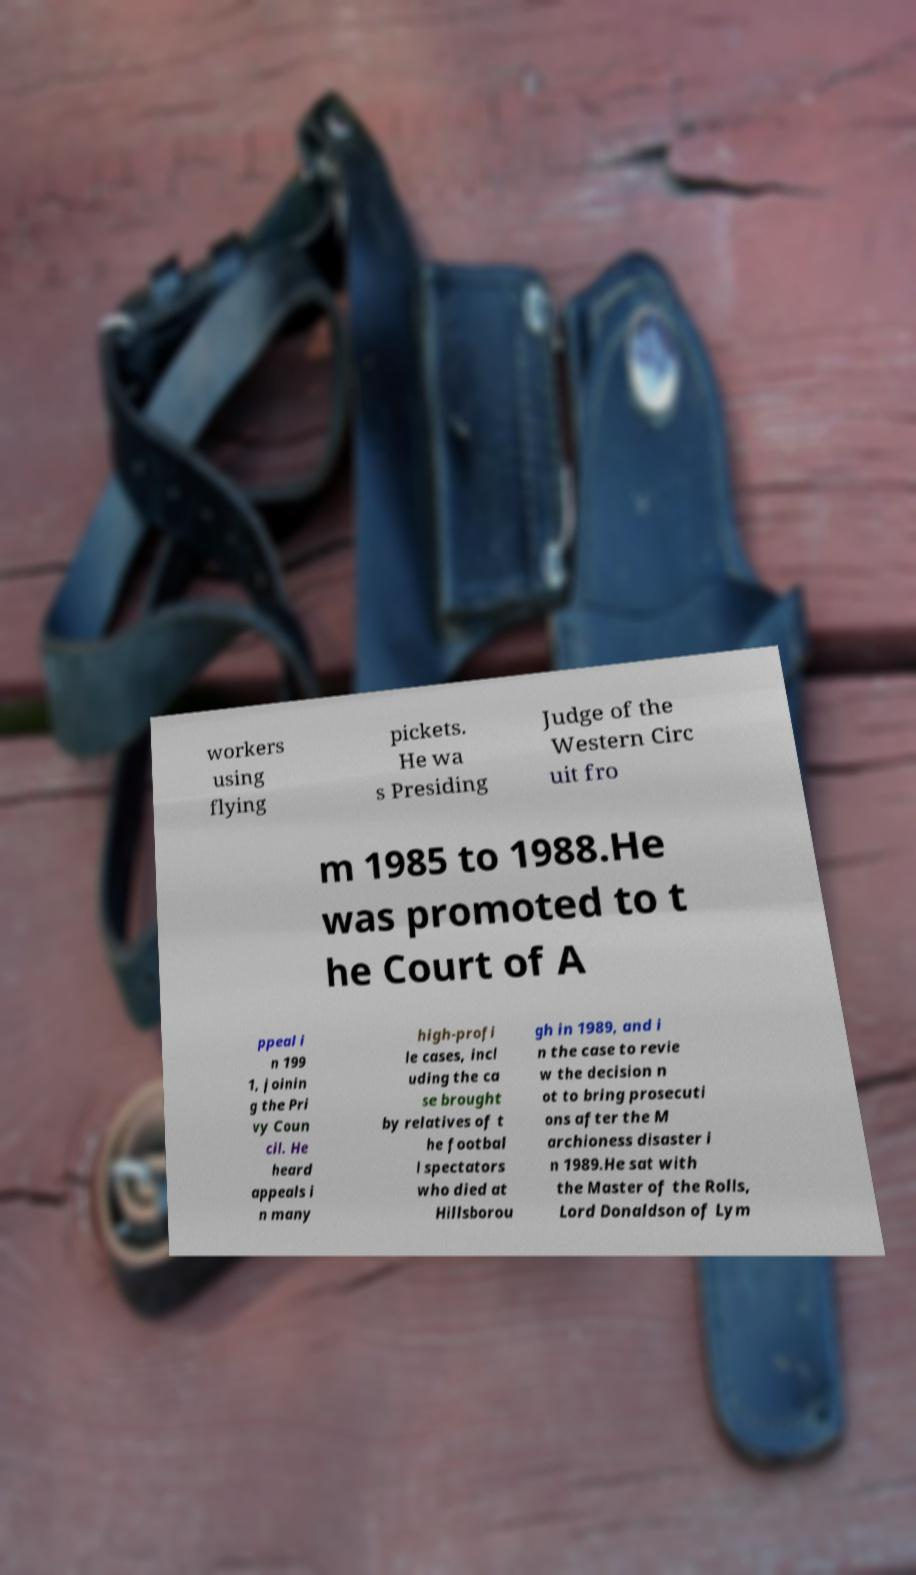What messages or text are displayed in this image? I need them in a readable, typed format. workers using flying pickets. He wa s Presiding Judge of the Western Circ uit fro m 1985 to 1988.He was promoted to t he Court of A ppeal i n 199 1, joinin g the Pri vy Coun cil. He heard appeals i n many high-profi le cases, incl uding the ca se brought by relatives of t he footbal l spectators who died at Hillsborou gh in 1989, and i n the case to revie w the decision n ot to bring prosecuti ons after the M archioness disaster i n 1989.He sat with the Master of the Rolls, Lord Donaldson of Lym 